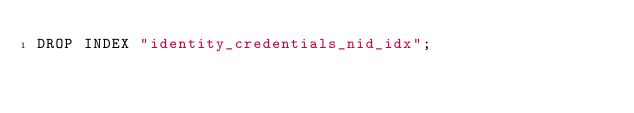Convert code to text. <code><loc_0><loc_0><loc_500><loc_500><_SQL_>DROP INDEX "identity_credentials_nid_idx";</code> 